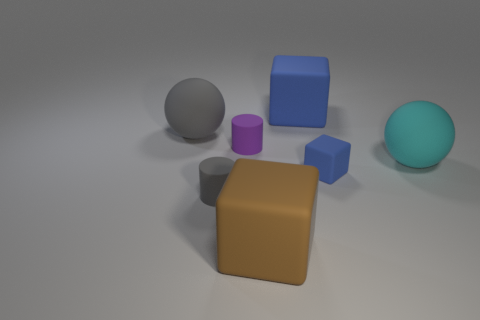Add 2 big balls. How many objects exist? 9 Subtract all spheres. How many objects are left? 5 Subtract all large cyan objects. Subtract all blue cubes. How many objects are left? 4 Add 6 purple cylinders. How many purple cylinders are left? 7 Add 1 brown blocks. How many brown blocks exist? 2 Subtract 0 blue cylinders. How many objects are left? 7 